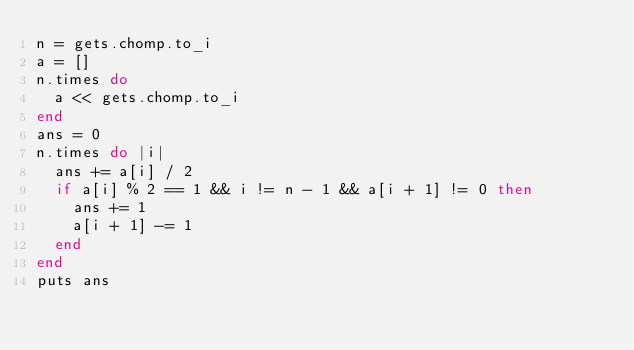<code> <loc_0><loc_0><loc_500><loc_500><_Ruby_>n = gets.chomp.to_i
a = []
n.times do
  a << gets.chomp.to_i
end
ans = 0
n.times do |i|
  ans += a[i] / 2
  if a[i] % 2 == 1 && i != n - 1 && a[i + 1] != 0 then
    ans += 1
    a[i + 1] -= 1
  end
end
puts ans
</code> 